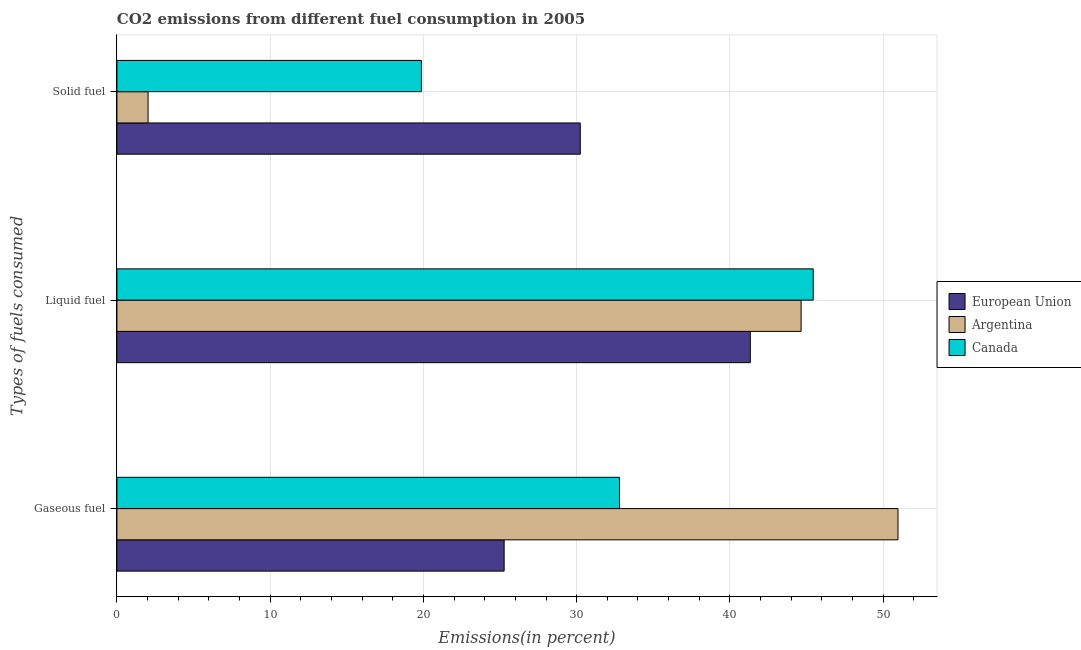How many different coloured bars are there?
Keep it short and to the point. 3. What is the label of the 2nd group of bars from the top?
Ensure brevity in your answer.  Liquid fuel. What is the percentage of solid fuel emission in European Union?
Offer a very short reply. 30.24. Across all countries, what is the maximum percentage of gaseous fuel emission?
Offer a very short reply. 50.97. Across all countries, what is the minimum percentage of solid fuel emission?
Give a very brief answer. 2.03. In which country was the percentage of solid fuel emission maximum?
Offer a terse response. European Union. In which country was the percentage of gaseous fuel emission minimum?
Give a very brief answer. European Union. What is the total percentage of solid fuel emission in the graph?
Offer a terse response. 52.14. What is the difference between the percentage of liquid fuel emission in Canada and that in European Union?
Your answer should be compact. 4.11. What is the difference between the percentage of liquid fuel emission in Canada and the percentage of gaseous fuel emission in European Union?
Provide a short and direct response. 20.17. What is the average percentage of liquid fuel emission per country?
Your answer should be very brief. 43.8. What is the difference between the percentage of gaseous fuel emission and percentage of liquid fuel emission in Canada?
Keep it short and to the point. -12.64. What is the ratio of the percentage of solid fuel emission in European Union to that in Canada?
Offer a terse response. 1.52. Is the percentage of liquid fuel emission in European Union less than that in Canada?
Ensure brevity in your answer.  Yes. What is the difference between the highest and the second highest percentage of liquid fuel emission?
Provide a succinct answer. 0.79. What is the difference between the highest and the lowest percentage of gaseous fuel emission?
Your answer should be compact. 25.7. In how many countries, is the percentage of solid fuel emission greater than the average percentage of solid fuel emission taken over all countries?
Your answer should be compact. 2. What does the 2nd bar from the top in Solid fuel represents?
Offer a terse response. Argentina. What does the 2nd bar from the bottom in Liquid fuel represents?
Make the answer very short. Argentina. Are all the bars in the graph horizontal?
Your response must be concise. Yes. What is the difference between two consecutive major ticks on the X-axis?
Give a very brief answer. 10. Are the values on the major ticks of X-axis written in scientific E-notation?
Provide a succinct answer. No. Does the graph contain grids?
Your answer should be very brief. Yes. Where does the legend appear in the graph?
Provide a succinct answer. Center right. How many legend labels are there?
Your answer should be very brief. 3. What is the title of the graph?
Ensure brevity in your answer.  CO2 emissions from different fuel consumption in 2005. Does "Vanuatu" appear as one of the legend labels in the graph?
Make the answer very short. No. What is the label or title of the X-axis?
Your response must be concise. Emissions(in percent). What is the label or title of the Y-axis?
Your answer should be compact. Types of fuels consumed. What is the Emissions(in percent) in European Union in Gaseous fuel?
Give a very brief answer. 25.27. What is the Emissions(in percent) in Argentina in Gaseous fuel?
Keep it short and to the point. 50.97. What is the Emissions(in percent) of Canada in Gaseous fuel?
Make the answer very short. 32.79. What is the Emissions(in percent) of European Union in Liquid fuel?
Offer a very short reply. 41.33. What is the Emissions(in percent) of Argentina in Liquid fuel?
Provide a short and direct response. 44.65. What is the Emissions(in percent) of Canada in Liquid fuel?
Keep it short and to the point. 45.44. What is the Emissions(in percent) in European Union in Solid fuel?
Your response must be concise. 30.24. What is the Emissions(in percent) of Argentina in Solid fuel?
Ensure brevity in your answer.  2.03. What is the Emissions(in percent) of Canada in Solid fuel?
Provide a short and direct response. 19.87. Across all Types of fuels consumed, what is the maximum Emissions(in percent) of European Union?
Give a very brief answer. 41.33. Across all Types of fuels consumed, what is the maximum Emissions(in percent) of Argentina?
Give a very brief answer. 50.97. Across all Types of fuels consumed, what is the maximum Emissions(in percent) in Canada?
Offer a very short reply. 45.44. Across all Types of fuels consumed, what is the minimum Emissions(in percent) of European Union?
Offer a very short reply. 25.27. Across all Types of fuels consumed, what is the minimum Emissions(in percent) in Argentina?
Ensure brevity in your answer.  2.03. Across all Types of fuels consumed, what is the minimum Emissions(in percent) in Canada?
Provide a succinct answer. 19.87. What is the total Emissions(in percent) of European Union in the graph?
Ensure brevity in your answer.  96.84. What is the total Emissions(in percent) of Argentina in the graph?
Ensure brevity in your answer.  97.65. What is the total Emissions(in percent) in Canada in the graph?
Offer a terse response. 98.1. What is the difference between the Emissions(in percent) of European Union in Gaseous fuel and that in Liquid fuel?
Your answer should be very brief. -16.06. What is the difference between the Emissions(in percent) in Argentina in Gaseous fuel and that in Liquid fuel?
Make the answer very short. 6.32. What is the difference between the Emissions(in percent) of Canada in Gaseous fuel and that in Liquid fuel?
Provide a short and direct response. -12.64. What is the difference between the Emissions(in percent) of European Union in Gaseous fuel and that in Solid fuel?
Your answer should be compact. -4.97. What is the difference between the Emissions(in percent) of Argentina in Gaseous fuel and that in Solid fuel?
Give a very brief answer. 48.94. What is the difference between the Emissions(in percent) in Canada in Gaseous fuel and that in Solid fuel?
Your answer should be very brief. 12.93. What is the difference between the Emissions(in percent) in European Union in Liquid fuel and that in Solid fuel?
Make the answer very short. 11.09. What is the difference between the Emissions(in percent) in Argentina in Liquid fuel and that in Solid fuel?
Provide a succinct answer. 42.61. What is the difference between the Emissions(in percent) in Canada in Liquid fuel and that in Solid fuel?
Keep it short and to the point. 25.57. What is the difference between the Emissions(in percent) of European Union in Gaseous fuel and the Emissions(in percent) of Argentina in Liquid fuel?
Make the answer very short. -19.38. What is the difference between the Emissions(in percent) in European Union in Gaseous fuel and the Emissions(in percent) in Canada in Liquid fuel?
Your answer should be compact. -20.17. What is the difference between the Emissions(in percent) of Argentina in Gaseous fuel and the Emissions(in percent) of Canada in Liquid fuel?
Provide a short and direct response. 5.53. What is the difference between the Emissions(in percent) in European Union in Gaseous fuel and the Emissions(in percent) in Argentina in Solid fuel?
Your response must be concise. 23.24. What is the difference between the Emissions(in percent) of European Union in Gaseous fuel and the Emissions(in percent) of Canada in Solid fuel?
Ensure brevity in your answer.  5.4. What is the difference between the Emissions(in percent) in Argentina in Gaseous fuel and the Emissions(in percent) in Canada in Solid fuel?
Ensure brevity in your answer.  31.1. What is the difference between the Emissions(in percent) in European Union in Liquid fuel and the Emissions(in percent) in Argentina in Solid fuel?
Keep it short and to the point. 39.3. What is the difference between the Emissions(in percent) in European Union in Liquid fuel and the Emissions(in percent) in Canada in Solid fuel?
Your answer should be very brief. 21.46. What is the difference between the Emissions(in percent) of Argentina in Liquid fuel and the Emissions(in percent) of Canada in Solid fuel?
Your answer should be compact. 24.78. What is the average Emissions(in percent) in European Union per Types of fuels consumed?
Offer a terse response. 32.28. What is the average Emissions(in percent) in Argentina per Types of fuels consumed?
Ensure brevity in your answer.  32.55. What is the average Emissions(in percent) in Canada per Types of fuels consumed?
Your answer should be very brief. 32.7. What is the difference between the Emissions(in percent) in European Union and Emissions(in percent) in Argentina in Gaseous fuel?
Offer a very short reply. -25.7. What is the difference between the Emissions(in percent) of European Union and Emissions(in percent) of Canada in Gaseous fuel?
Offer a very short reply. -7.53. What is the difference between the Emissions(in percent) in Argentina and Emissions(in percent) in Canada in Gaseous fuel?
Ensure brevity in your answer.  18.17. What is the difference between the Emissions(in percent) in European Union and Emissions(in percent) in Argentina in Liquid fuel?
Provide a short and direct response. -3.32. What is the difference between the Emissions(in percent) in European Union and Emissions(in percent) in Canada in Liquid fuel?
Make the answer very short. -4.11. What is the difference between the Emissions(in percent) of Argentina and Emissions(in percent) of Canada in Liquid fuel?
Ensure brevity in your answer.  -0.79. What is the difference between the Emissions(in percent) of European Union and Emissions(in percent) of Argentina in Solid fuel?
Offer a terse response. 28.2. What is the difference between the Emissions(in percent) of European Union and Emissions(in percent) of Canada in Solid fuel?
Your answer should be compact. 10.37. What is the difference between the Emissions(in percent) in Argentina and Emissions(in percent) in Canada in Solid fuel?
Give a very brief answer. -17.84. What is the ratio of the Emissions(in percent) of European Union in Gaseous fuel to that in Liquid fuel?
Offer a terse response. 0.61. What is the ratio of the Emissions(in percent) of Argentina in Gaseous fuel to that in Liquid fuel?
Provide a succinct answer. 1.14. What is the ratio of the Emissions(in percent) in Canada in Gaseous fuel to that in Liquid fuel?
Provide a succinct answer. 0.72. What is the ratio of the Emissions(in percent) in European Union in Gaseous fuel to that in Solid fuel?
Provide a succinct answer. 0.84. What is the ratio of the Emissions(in percent) of Argentina in Gaseous fuel to that in Solid fuel?
Ensure brevity in your answer.  25.08. What is the ratio of the Emissions(in percent) of Canada in Gaseous fuel to that in Solid fuel?
Provide a short and direct response. 1.65. What is the ratio of the Emissions(in percent) of European Union in Liquid fuel to that in Solid fuel?
Provide a short and direct response. 1.37. What is the ratio of the Emissions(in percent) of Argentina in Liquid fuel to that in Solid fuel?
Your response must be concise. 21.97. What is the ratio of the Emissions(in percent) in Canada in Liquid fuel to that in Solid fuel?
Your response must be concise. 2.29. What is the difference between the highest and the second highest Emissions(in percent) of European Union?
Provide a short and direct response. 11.09. What is the difference between the highest and the second highest Emissions(in percent) in Argentina?
Your answer should be compact. 6.32. What is the difference between the highest and the second highest Emissions(in percent) of Canada?
Offer a terse response. 12.64. What is the difference between the highest and the lowest Emissions(in percent) of European Union?
Keep it short and to the point. 16.06. What is the difference between the highest and the lowest Emissions(in percent) in Argentina?
Ensure brevity in your answer.  48.94. What is the difference between the highest and the lowest Emissions(in percent) of Canada?
Ensure brevity in your answer.  25.57. 